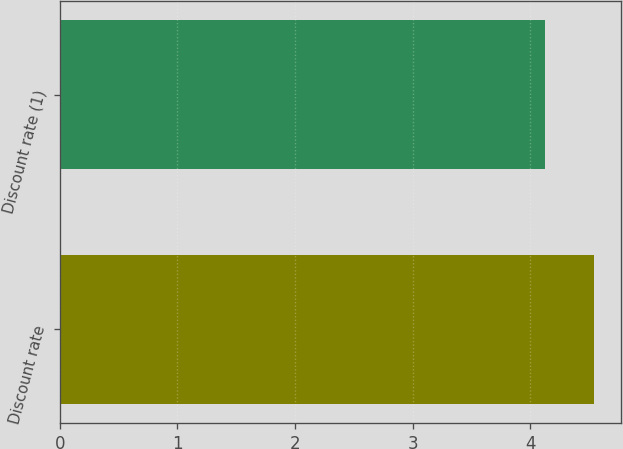Convert chart. <chart><loc_0><loc_0><loc_500><loc_500><bar_chart><fcel>Discount rate<fcel>Discount rate (1)<nl><fcel>4.54<fcel>4.12<nl></chart> 